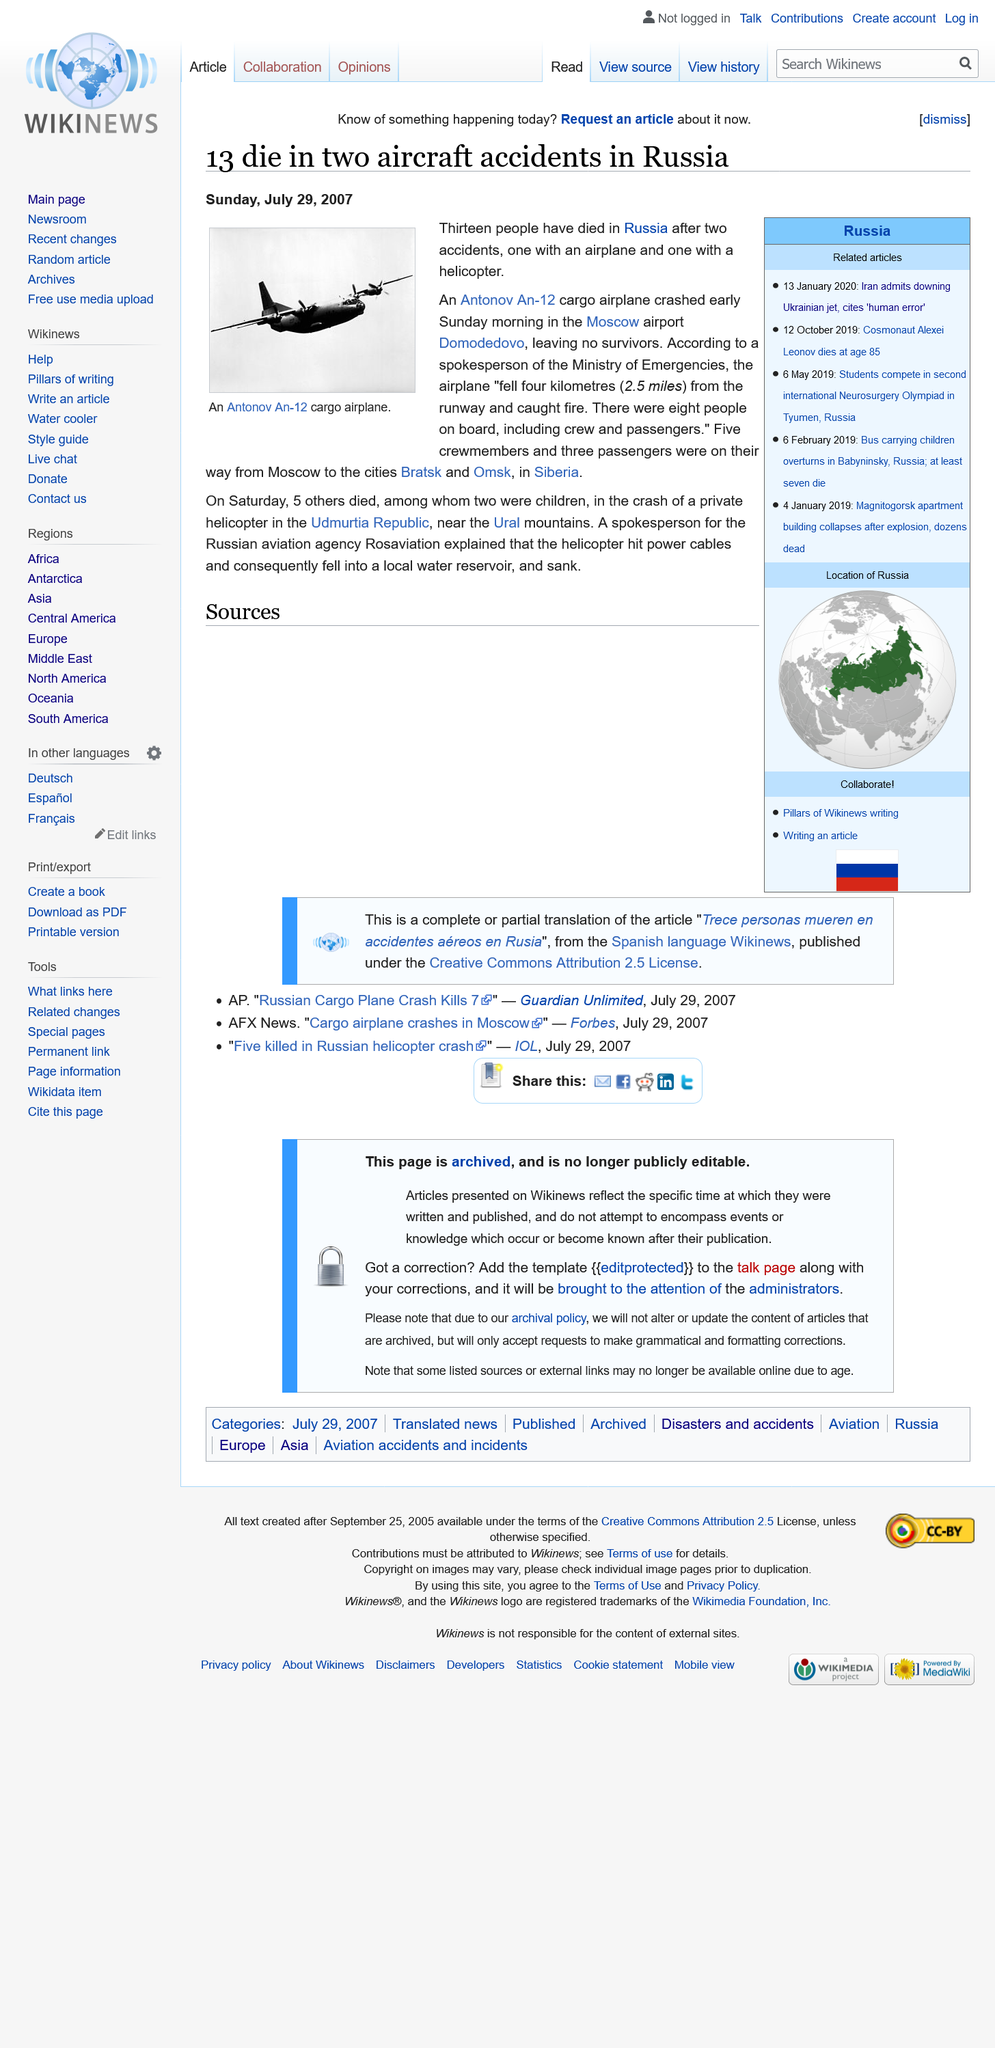Give some essential details in this illustration. The article was published on July 29th, 2007. The airplane in the photo is an Antonov An-12 cargo airplane, which is a specific type of aircraft. The Russian aviation agency, Rosaviation, explained that a helicopter was involved in an accident due to hitting power cables. 